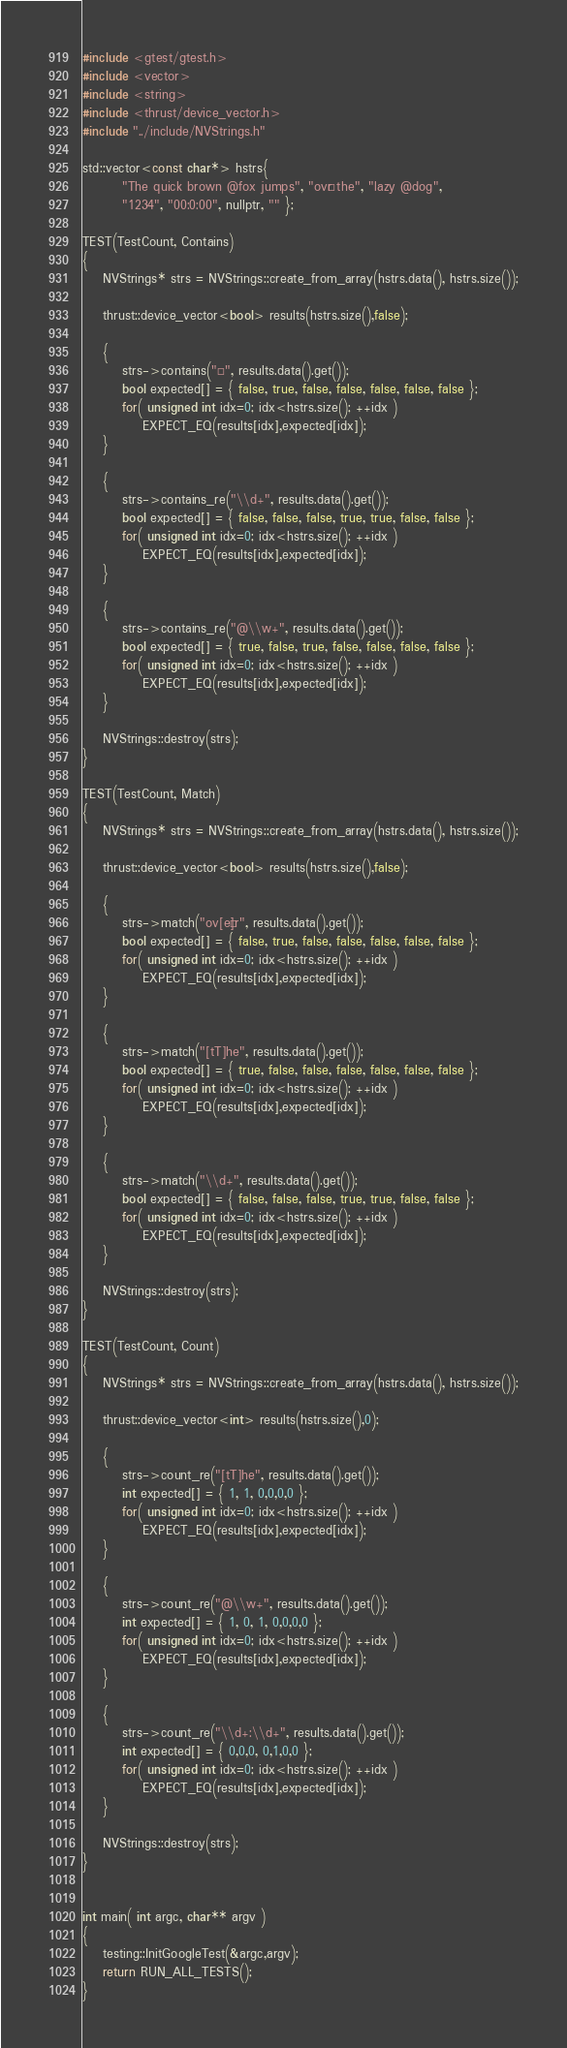<code> <loc_0><loc_0><loc_500><loc_500><_Cuda_>
#include <gtest/gtest.h>
#include <vector>
#include <string>
#include <thrust/device_vector.h>
#include "../include/NVStrings.h"

std::vector<const char*> hstrs{
        "The quick brown @fox jumps", "ovér the", "lazy @dog",
        "1234", "00:0:00", nullptr, "" };

TEST(TestCount, Contains)
{
    NVStrings* strs = NVStrings::create_from_array(hstrs.data(), hstrs.size());

    thrust::device_vector<bool> results(hstrs.size(),false);

    {
        strs->contains("é", results.data().get());
        bool expected[] = { false, true, false, false, false, false, false };
        for( unsigned int idx=0; idx<hstrs.size(); ++idx )
            EXPECT_EQ(results[idx],expected[idx]);
    }

    {
        strs->contains_re("\\d+", results.data().get());
        bool expected[] = { false, false, false, true, true, false, false };
        for( unsigned int idx=0; idx<hstrs.size(); ++idx )
            EXPECT_EQ(results[idx],expected[idx]);
    }

    {
        strs->contains_re("@\\w+", results.data().get());
        bool expected[] = { true, false, true, false, false, false, false };
        for( unsigned int idx=0; idx<hstrs.size(); ++idx )
            EXPECT_EQ(results[idx],expected[idx]);
    }

    NVStrings::destroy(strs);
}

TEST(TestCount, Match)
{
    NVStrings* strs = NVStrings::create_from_array(hstrs.data(), hstrs.size());

    thrust::device_vector<bool> results(hstrs.size(),false);

    {
        strs->match("ov[eé]r", results.data().get());
        bool expected[] = { false, true, false, false, false, false, false };
        for( unsigned int idx=0; idx<hstrs.size(); ++idx )
            EXPECT_EQ(results[idx],expected[idx]);
    }

    {
        strs->match("[tT]he", results.data().get());
        bool expected[] = { true, false, false, false, false, false, false };
        for( unsigned int idx=0; idx<hstrs.size(); ++idx )
            EXPECT_EQ(results[idx],expected[idx]);
    }

    {
        strs->match("\\d+", results.data().get());
        bool expected[] = { false, false, false, true, true, false, false };
        for( unsigned int idx=0; idx<hstrs.size(); ++idx )
            EXPECT_EQ(results[idx],expected[idx]);
    }

    NVStrings::destroy(strs);
}

TEST(TestCount, Count)
{
    NVStrings* strs = NVStrings::create_from_array(hstrs.data(), hstrs.size());

    thrust::device_vector<int> results(hstrs.size(),0);

    {
        strs->count_re("[tT]he", results.data().get());
        int expected[] = { 1, 1, 0,0,0,0 };
        for( unsigned int idx=0; idx<hstrs.size(); ++idx )
            EXPECT_EQ(results[idx],expected[idx]);
    }

    {
        strs->count_re("@\\w+", results.data().get());
        int expected[] = { 1, 0, 1, 0,0,0,0 };
        for( unsigned int idx=0; idx<hstrs.size(); ++idx )
            EXPECT_EQ(results[idx],expected[idx]);
    }

    {
        strs->count_re("\\d+:\\d+", results.data().get());
        int expected[] = { 0,0,0, 0,1,0,0 };
        for( unsigned int idx=0; idx<hstrs.size(); ++idx )
            EXPECT_EQ(results[idx],expected[idx]);
    }

    NVStrings::destroy(strs);
}


int main( int argc, char** argv )
{
    testing::InitGoogleTest(&argc,argv);
    return RUN_ALL_TESTS();
}</code> 